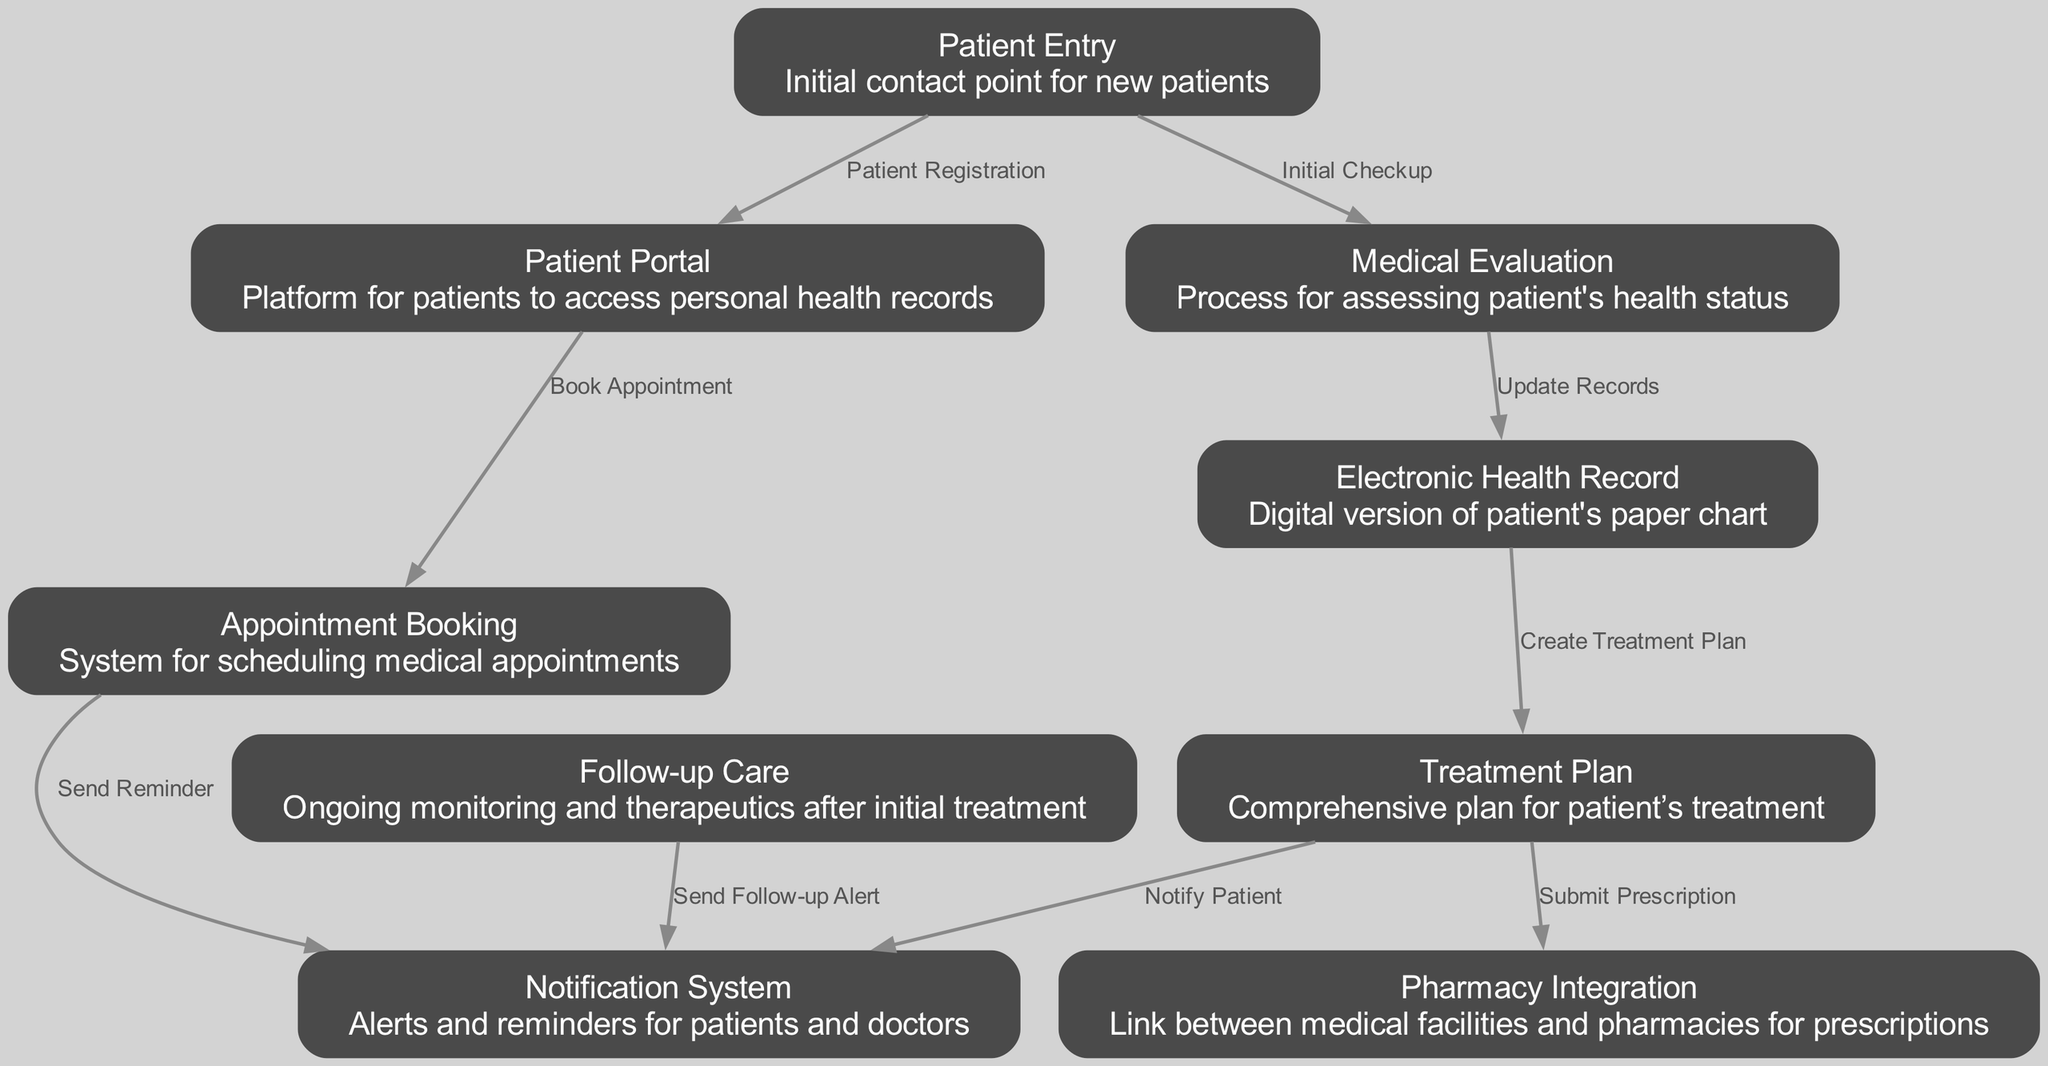What is the initial point of contact for new patients? The initial point of contact for new patients is represented by the "Patient Entry" node, which is clearly labeled at the top of the diagram.
Answer: Patient Entry How many nodes are present in the diagram? By counting all distinct elements categorized as nodes in the diagram, we find there are eleven nodes total.
Answer: 9 What relationship is defined between "Appointment Booking" and "Notification System"? The edge connecting "Appointment Booking" and "Notification System" indicates the action "Send Reminder," which defines their relationship therefore.
Answer: Send Reminder Which node receives the action of "Notify Patient"? The edge leading from the "Treatment Plan" node to the "Notification System" node indicates that the action of notifying the patient comes from the treatment plan process.
Answer: Notification System What process follows "Medical Evaluation"? The diagram shows that after "Medical Evaluation," the next step is "Electronic Health Record," indicated by the connecting edge labeled "Update Records."
Answer: Electronic Health Record Which nodes are directly connected to "Patient Portal"? The "Patient Portal" node has two direct outgoing connections, one to "Appointment Booking" and the other to "Patient Entry."
Answer: Appointment Booking, Patient Entry How many edges are there in this diagram? Counting all the connections (edges) between nodes in the diagram reveals a total of eight relationships represented.
Answer: 8 What action is taken after a "Treatment Plan" is created? The edge from "Treatment Plan" to "Notification System" signifies that one action after its creation is to notify the patient.
Answer: Notify Patient What is the purpose of the "Follow-up Care" node? The "Follow-up Care" node refers to ongoing monitoring and therapeutics after initial treatment, as described in its label.
Answer: Ongoing monitoring and therapeutics 